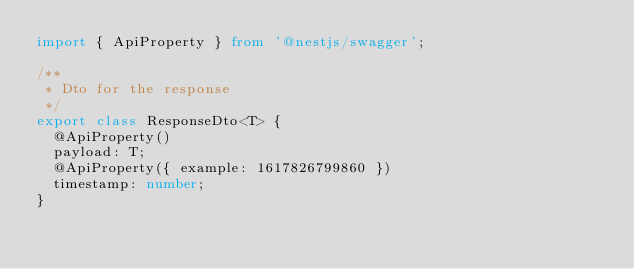<code> <loc_0><loc_0><loc_500><loc_500><_TypeScript_>import { ApiProperty } from '@nestjs/swagger';

/**
 * Dto for the response
 */
export class ResponseDto<T> {
  @ApiProperty()
  payload: T;
  @ApiProperty({ example: 1617826799860 })
  timestamp: number;
}
</code> 